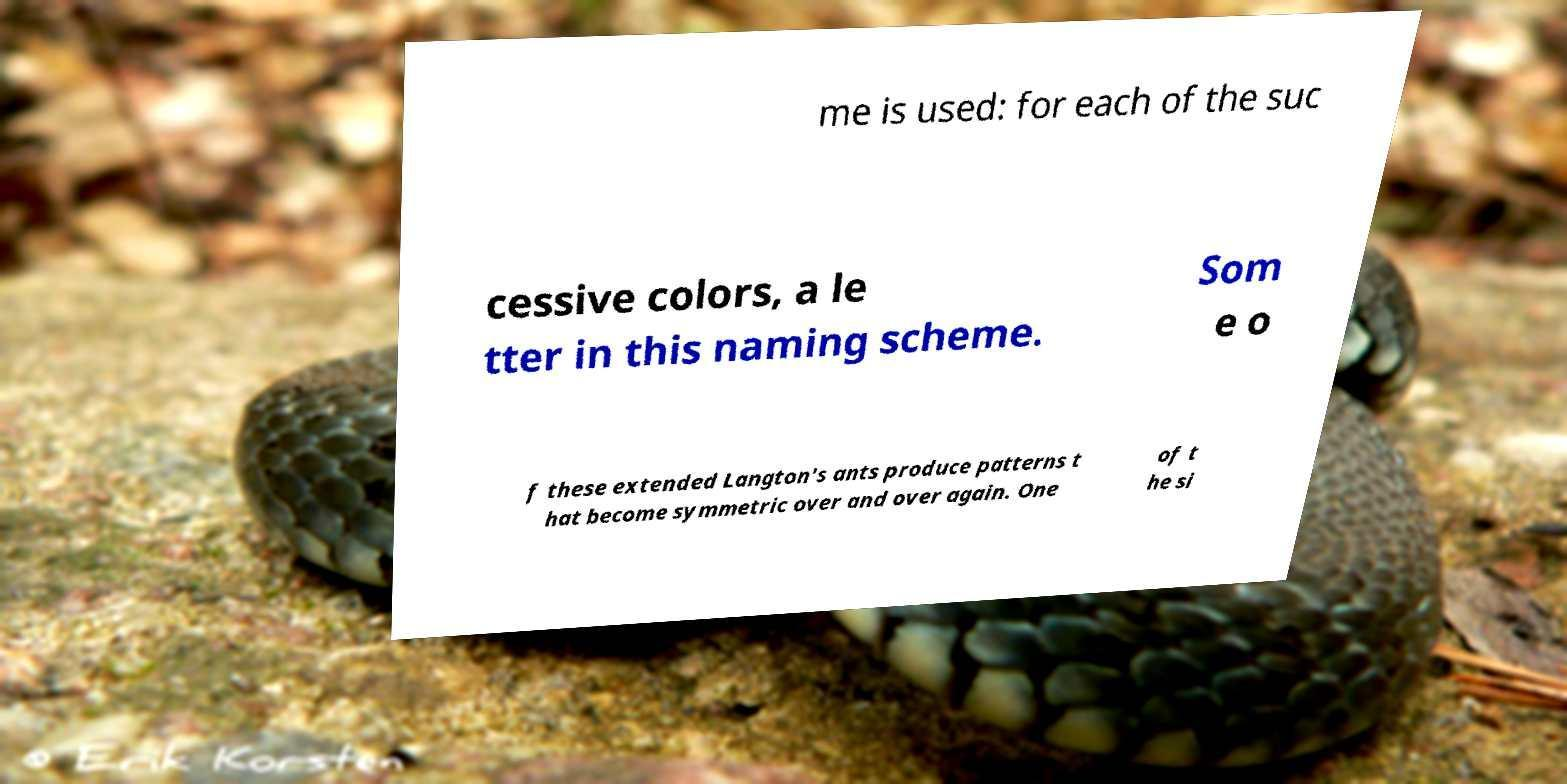Can you accurately transcribe the text from the provided image for me? me is used: for each of the suc cessive colors, a le tter in this naming scheme. Som e o f these extended Langton's ants produce patterns t hat become symmetric over and over again. One of t he si 